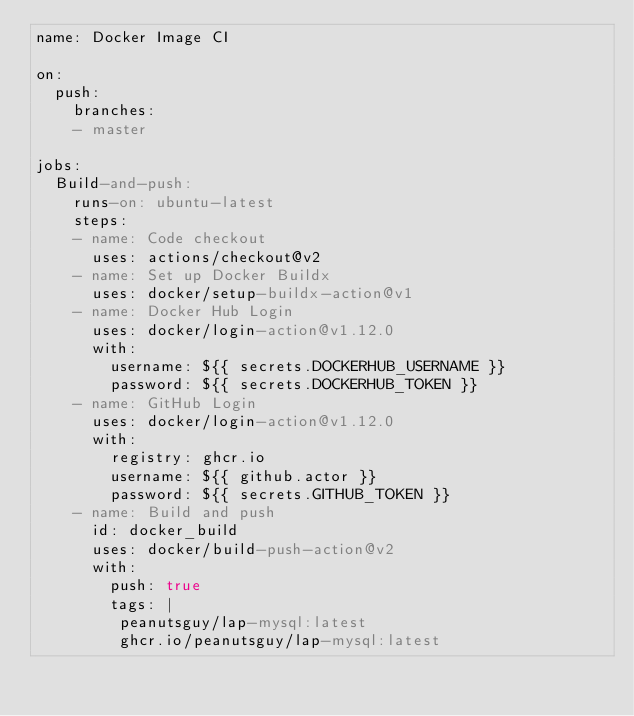<code> <loc_0><loc_0><loc_500><loc_500><_YAML_>name: Docker Image CI

on:
  push:
    branches:
    - master

jobs:
  Build-and-push:
    runs-on: ubuntu-latest
    steps:
    - name: Code checkout
      uses: actions/checkout@v2
    - name: Set up Docker Buildx
      uses: docker/setup-buildx-action@v1
    - name: Docker Hub Login
      uses: docker/login-action@v1.12.0
      with:
        username: ${{ secrets.DOCKERHUB_USERNAME }}
        password: ${{ secrets.DOCKERHUB_TOKEN }}
    - name: GitHub Login
      uses: docker/login-action@v1.12.0
      with:
        registry: ghcr.io
        username: ${{ github.actor }}
        password: ${{ secrets.GITHUB_TOKEN }}
    - name: Build and push
      id: docker_build
      uses: docker/build-push-action@v2
      with:
        push: true
        tags: |
         peanutsguy/lap-mysql:latest
         ghcr.io/peanutsguy/lap-mysql:latest
</code> 